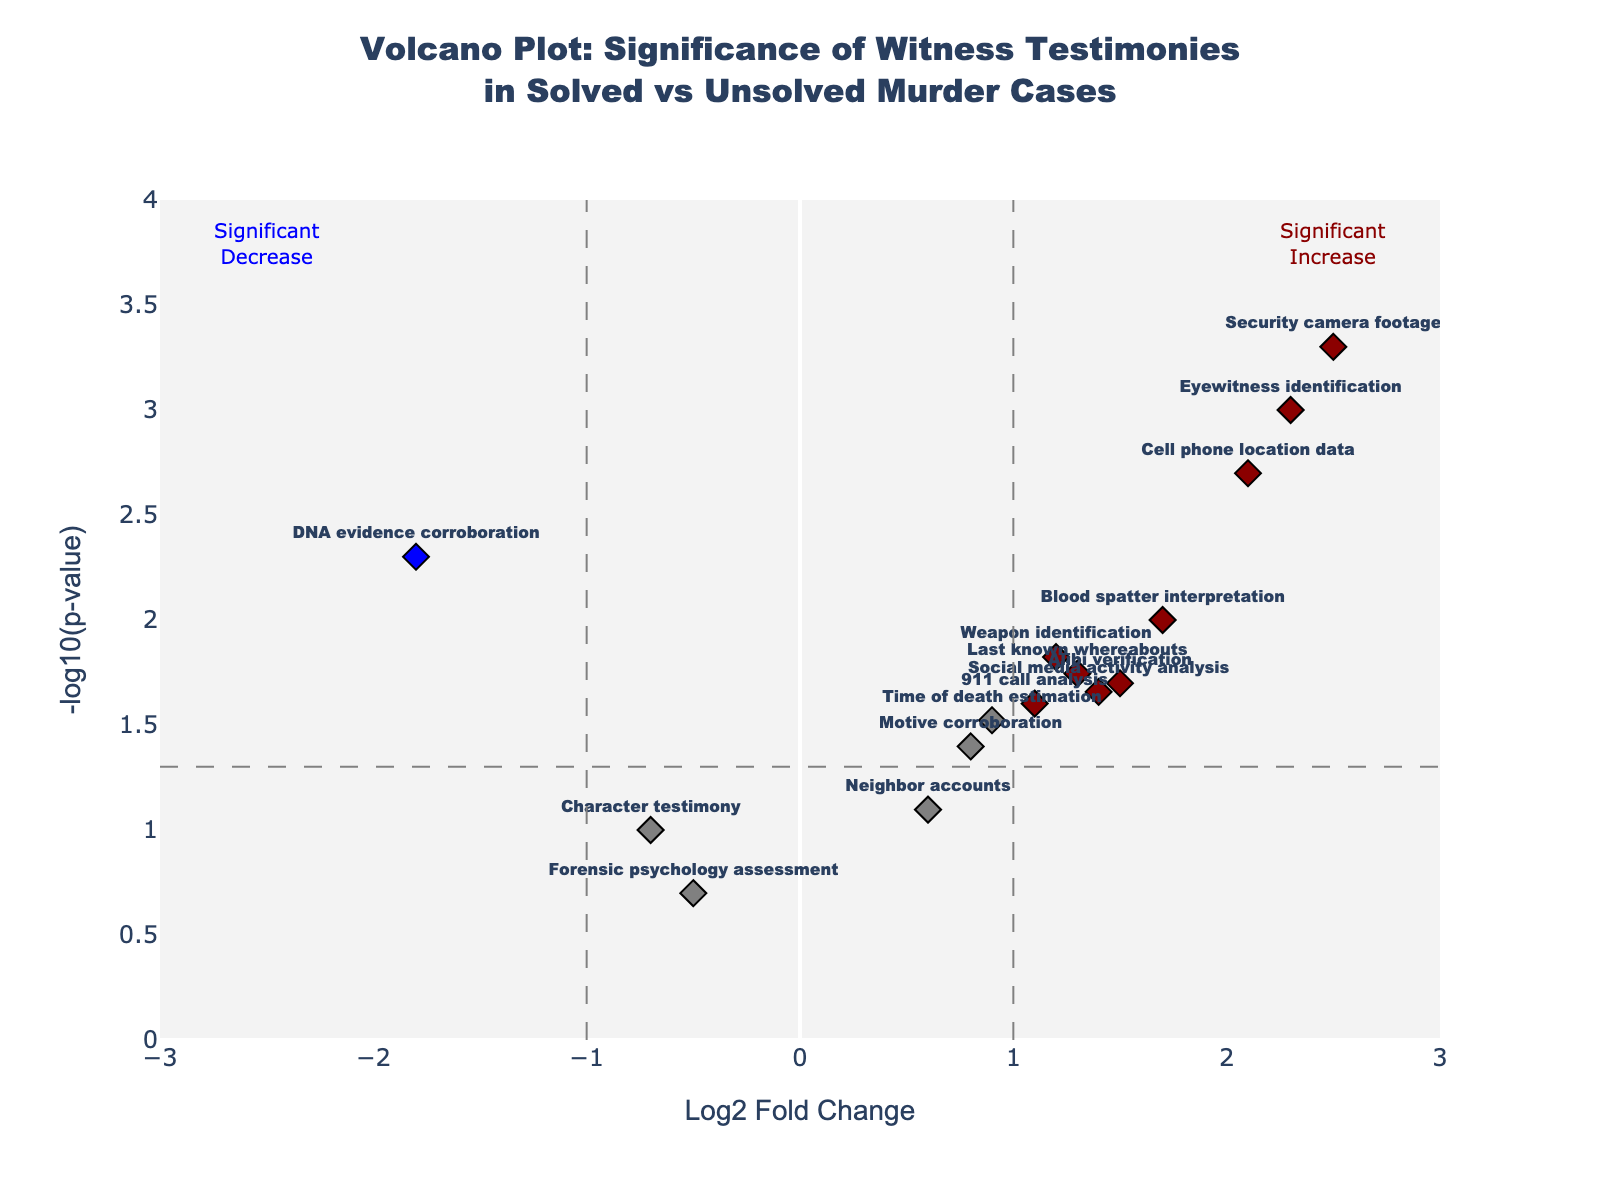What are the axes titles on the plot? The x-axis title is "Log2 Fold Change," and the y-axis title is "-log10(p-value)."
Answer: "Log2 Fold Change" and "-log10(p-value)" How many data points are marked as significant increases? There are six data points in dark red on the right side of the plot, representing significant increases.
Answer: 6 Which witness testimony data point has the highest log2 fold change value? The data point with the highest log2 fold change is "Security camera footage," which has a value of 2.5.
Answer: "Security camera footage" Which witness testimony data point has the lowest p-value? "Security camera footage" has the lowest p-value, which correlates with the highest -log10(p-value) on the plot.
Answer: "Security camera footage" Are there any data points that represent a significant decrease? If so, which ones? Yes, the data point "DNA evidence corroboration" in blue represents a significant decrease, with a log2 fold change of -1.8 and a p-value of 0.005.
Answer: "DNA evidence corroboration" How many data points fall within the non-significant region (gray color)? There are six data points within the non-significant region (gray color) as they do not meet the fold change or p-value significance thresholds.
Answer: 6 What is the range of values for -log10(p-value) on the y-axis? The y-axis range for -log10(p-value) goes from 0 to 4.
Answer: 0 to 4 Which witness testimonies fall into the significant decrease region? Only "DNA evidence corroboration" falls into the significant decrease region on the left side of the plot with negative log2 fold change and a low p-value.
Answer: "DNA evidence corroboration" How does the "Blood spatter interpretation" compare with "Weapon identification" in terms of log2 fold change and p-values? "Blood spatter interpretation" has a higher log2 fold change (1.7) compared to "Weapon identification" (1.2) and relatively close p-values (0.01 vs 0.015).
Answer: "Blood spatter interpretation" has a higher log2 fold change 